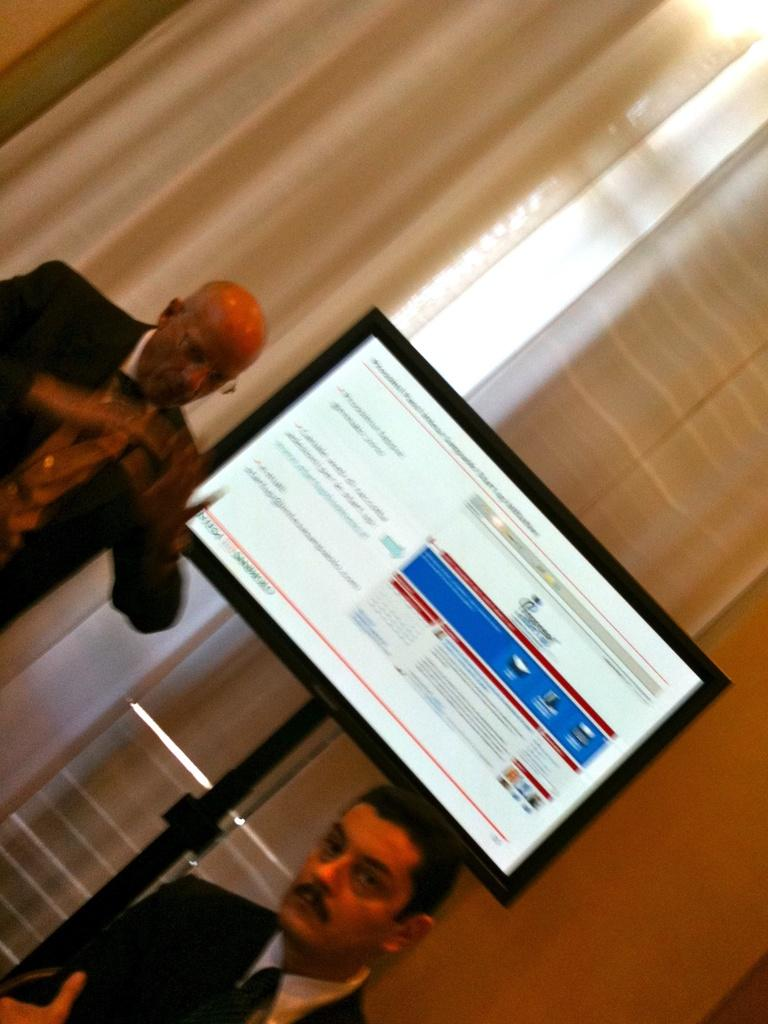How many men are in the image? There are two men in the image. Where are the men located in the image? The men are standing towards the left side of the image. What are the men wearing? The men are wearing suits. What can be seen in the center of the image? There is a television in the center of the image. What is behind the television? There are curtains behind the television. What type of balls are being used as an attraction in the image? There are no balls or attractions present in the image. 